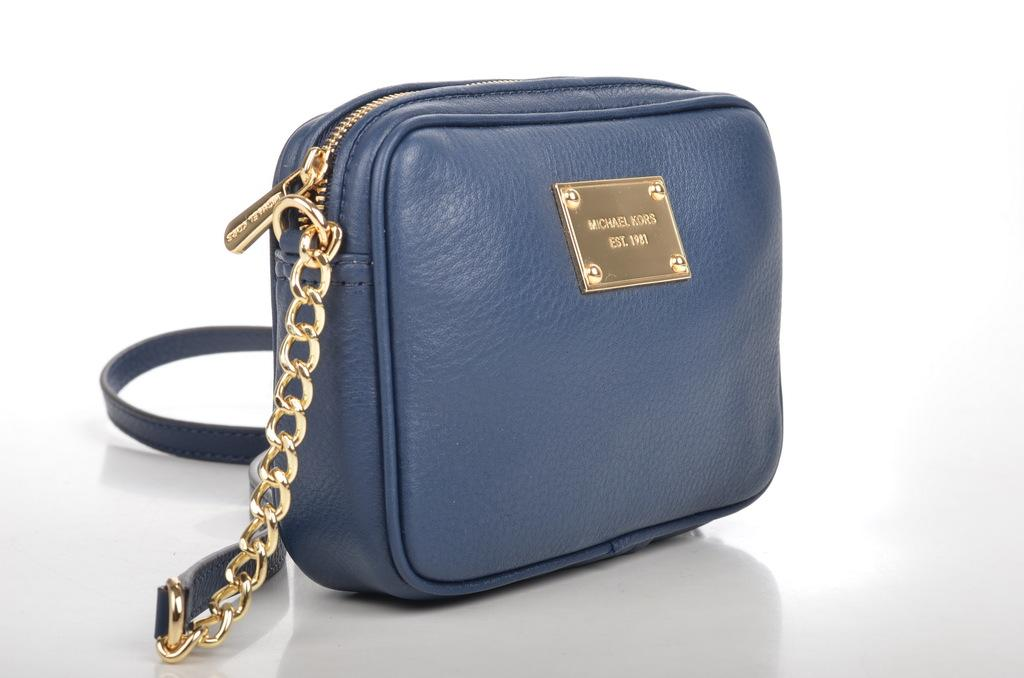What object can be seen in the image? There is a bag in the image. What color is the bag? The bag is blue in color. Are there any deer attacking children in the image? No, there are no deer or children present in the image. 